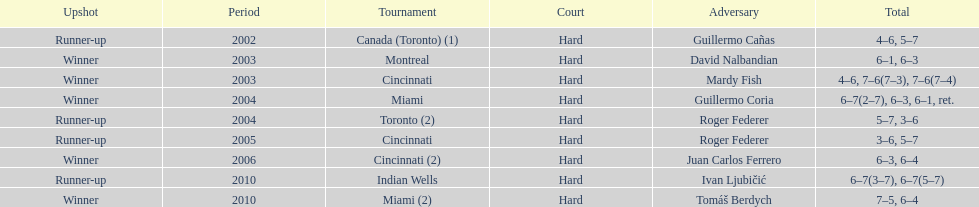What was the highest number of consecutive wins? 3. 